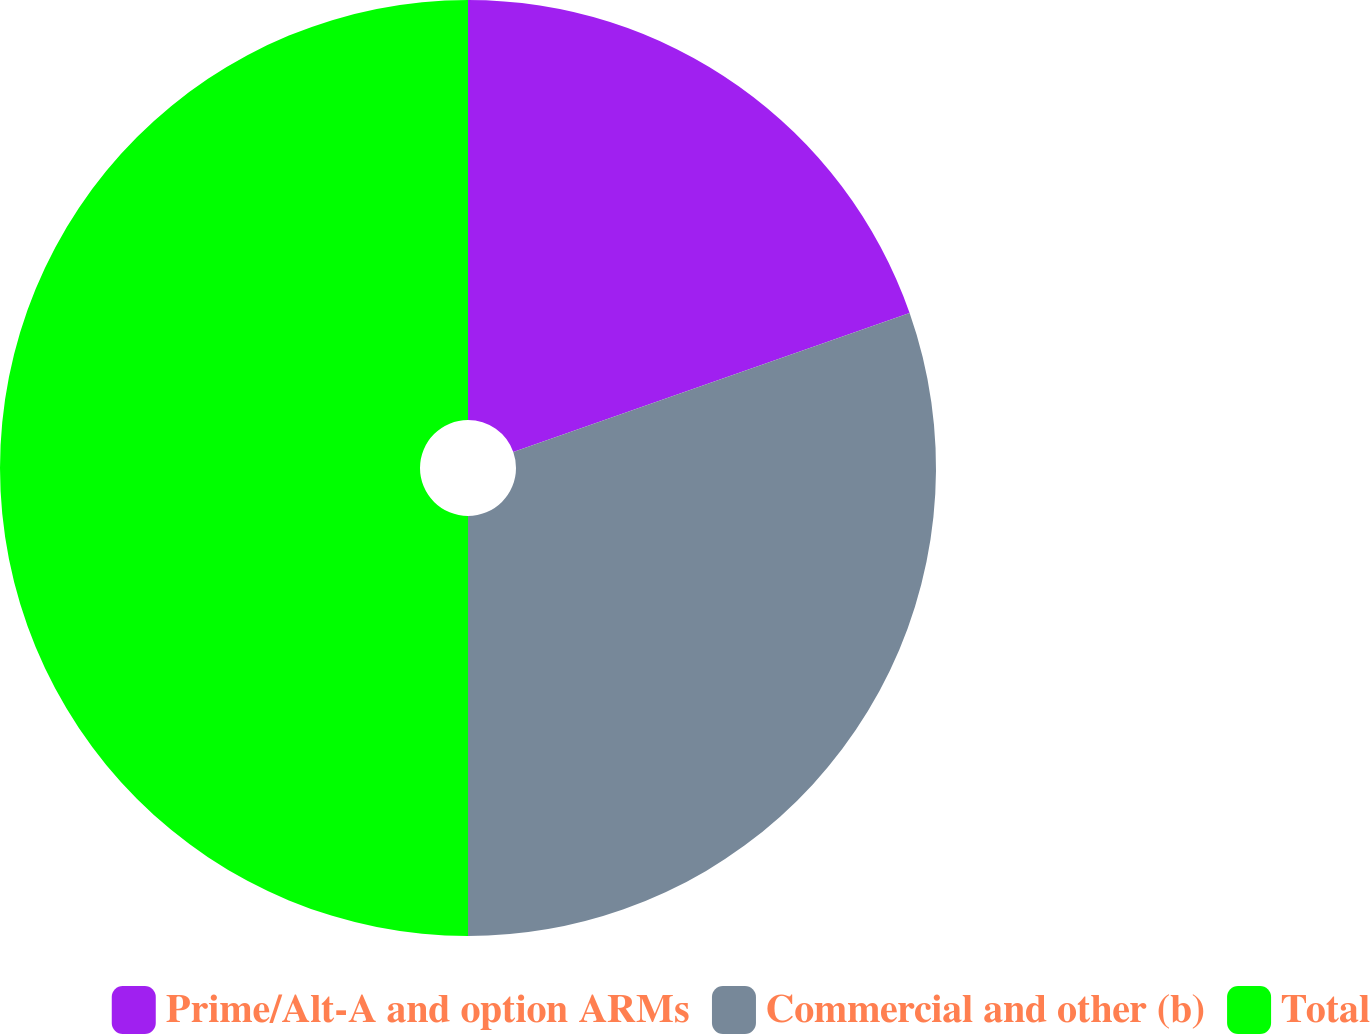<chart> <loc_0><loc_0><loc_500><loc_500><pie_chart><fcel>Prime/Alt-A and option ARMs<fcel>Commercial and other (b)<fcel>Total<nl><fcel>19.63%<fcel>30.37%<fcel>50.0%<nl></chart> 